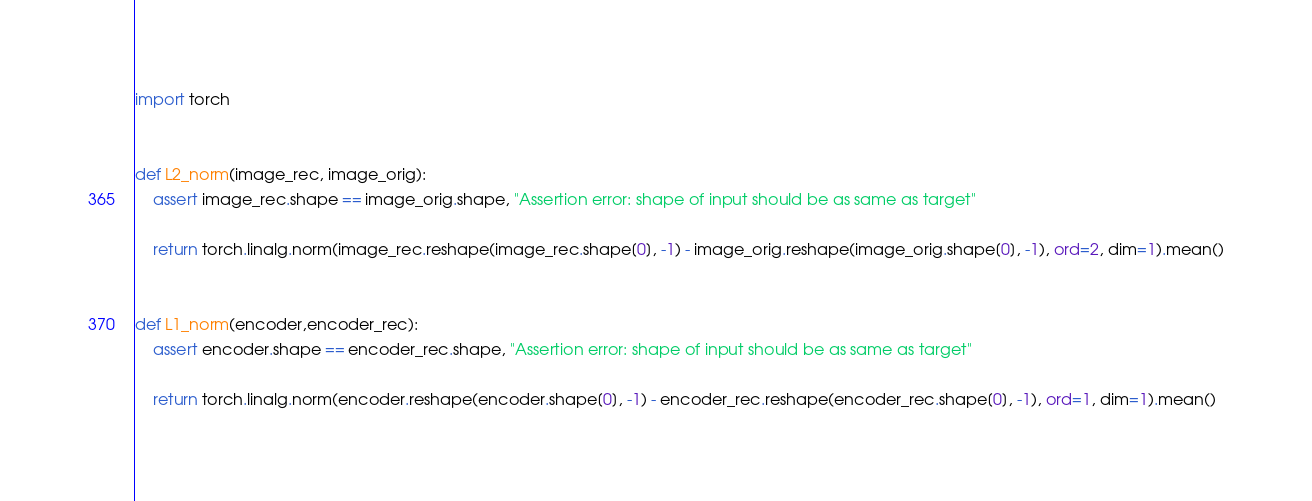<code> <loc_0><loc_0><loc_500><loc_500><_Python_>import torch


def L2_norm(image_rec, image_orig):
    assert image_rec.shape == image_orig.shape, "Assertion error: shape of input should be as same as target"

    return torch.linalg.norm(image_rec.reshape(image_rec.shape[0], -1) - image_orig.reshape(image_orig.shape[0], -1), ord=2, dim=1).mean()


def L1_norm(encoder,encoder_rec):
    assert encoder.shape == encoder_rec.shape, "Assertion error: shape of input should be as same as target"

    return torch.linalg.norm(encoder.reshape(encoder.shape[0], -1) - encoder_rec.reshape(encoder_rec.shape[0], -1), ord=1, dim=1).mean()

</code> 